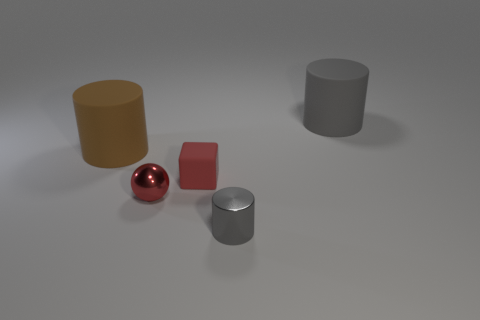Is the large cylinder on the right side of the tiny red shiny sphere made of the same material as the small red ball?
Provide a succinct answer. No. What is the size of the red shiny thing?
Make the answer very short. Small. What is the shape of the matte thing that is the same color as the metal cylinder?
Offer a terse response. Cylinder. How many cylinders are gray objects or large objects?
Keep it short and to the point. 3. Is the number of red blocks that are behind the brown cylinder the same as the number of gray things that are behind the rubber cube?
Give a very brief answer. No. What is the size of the brown object that is the same shape as the gray matte thing?
Provide a short and direct response. Large. What size is the cylinder that is to the right of the tiny cube and behind the red metallic thing?
Your response must be concise. Large. Are there any metallic cylinders behind the red cube?
Your response must be concise. No. How many things are either cylinders that are on the left side of the gray metal cylinder or small yellow rubber cubes?
Ensure brevity in your answer.  1. What number of big gray cylinders are on the left side of the big thing to the left of the tiny metallic ball?
Give a very brief answer. 0. 